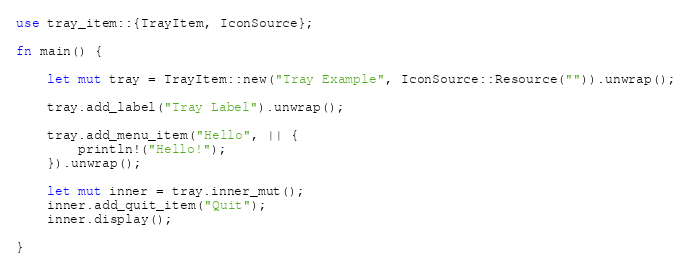<code> <loc_0><loc_0><loc_500><loc_500><_Rust_>use tray_item::{TrayItem, IconSource};

fn main() {

    let mut tray = TrayItem::new("Tray Example", IconSource::Resource("")).unwrap();

    tray.add_label("Tray Label").unwrap();

    tray.add_menu_item("Hello", || {
        println!("Hello!");
    }).unwrap();

    let mut inner = tray.inner_mut();
    inner.add_quit_item("Quit");
    inner.display();

}
</code> 